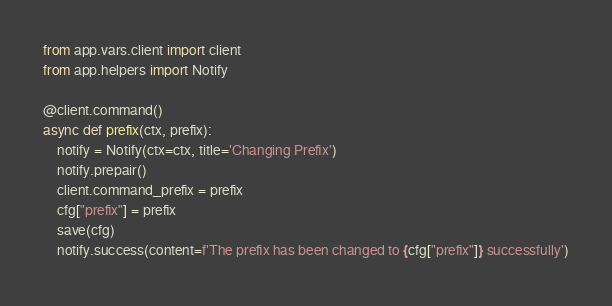Convert code to text. <code><loc_0><loc_0><loc_500><loc_500><_Python_>from app.vars.client import client
from app.helpers import Notify

@client.command()
async def prefix(ctx, prefix):
    notify = Notify(ctx=ctx, title='Changing Prefix')
    notify.prepair()
    client.command_prefix = prefix
    cfg["prefix"] = prefix
    save(cfg)
    notify.success(content=f'The prefix has been changed to {cfg["prefix"]} successfully')</code> 